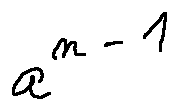<formula> <loc_0><loc_0><loc_500><loc_500>a ^ { n - 1 }</formula> 